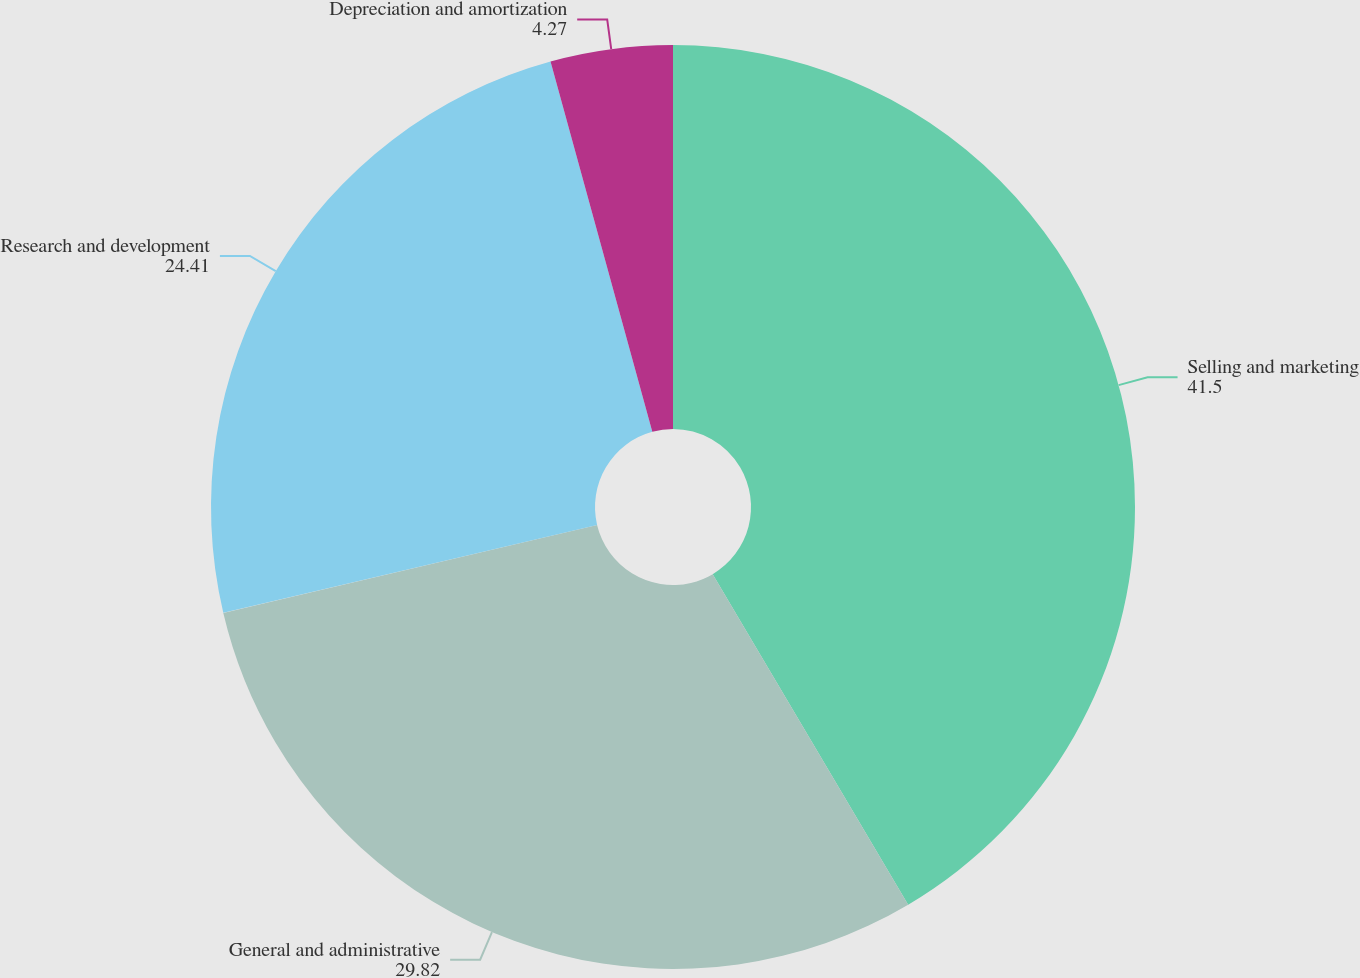Convert chart to OTSL. <chart><loc_0><loc_0><loc_500><loc_500><pie_chart><fcel>Selling and marketing<fcel>General and administrative<fcel>Research and development<fcel>Depreciation and amortization<nl><fcel>41.5%<fcel>29.82%<fcel>24.41%<fcel>4.27%<nl></chart> 